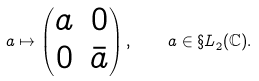Convert formula to latex. <formula><loc_0><loc_0><loc_500><loc_500>a \mapsto \begin{pmatrix} a & 0 \\ 0 & \bar { a } \end{pmatrix} , \quad a \in { \S L } _ { 2 } ( { \mathbb { C } } ) .</formula> 